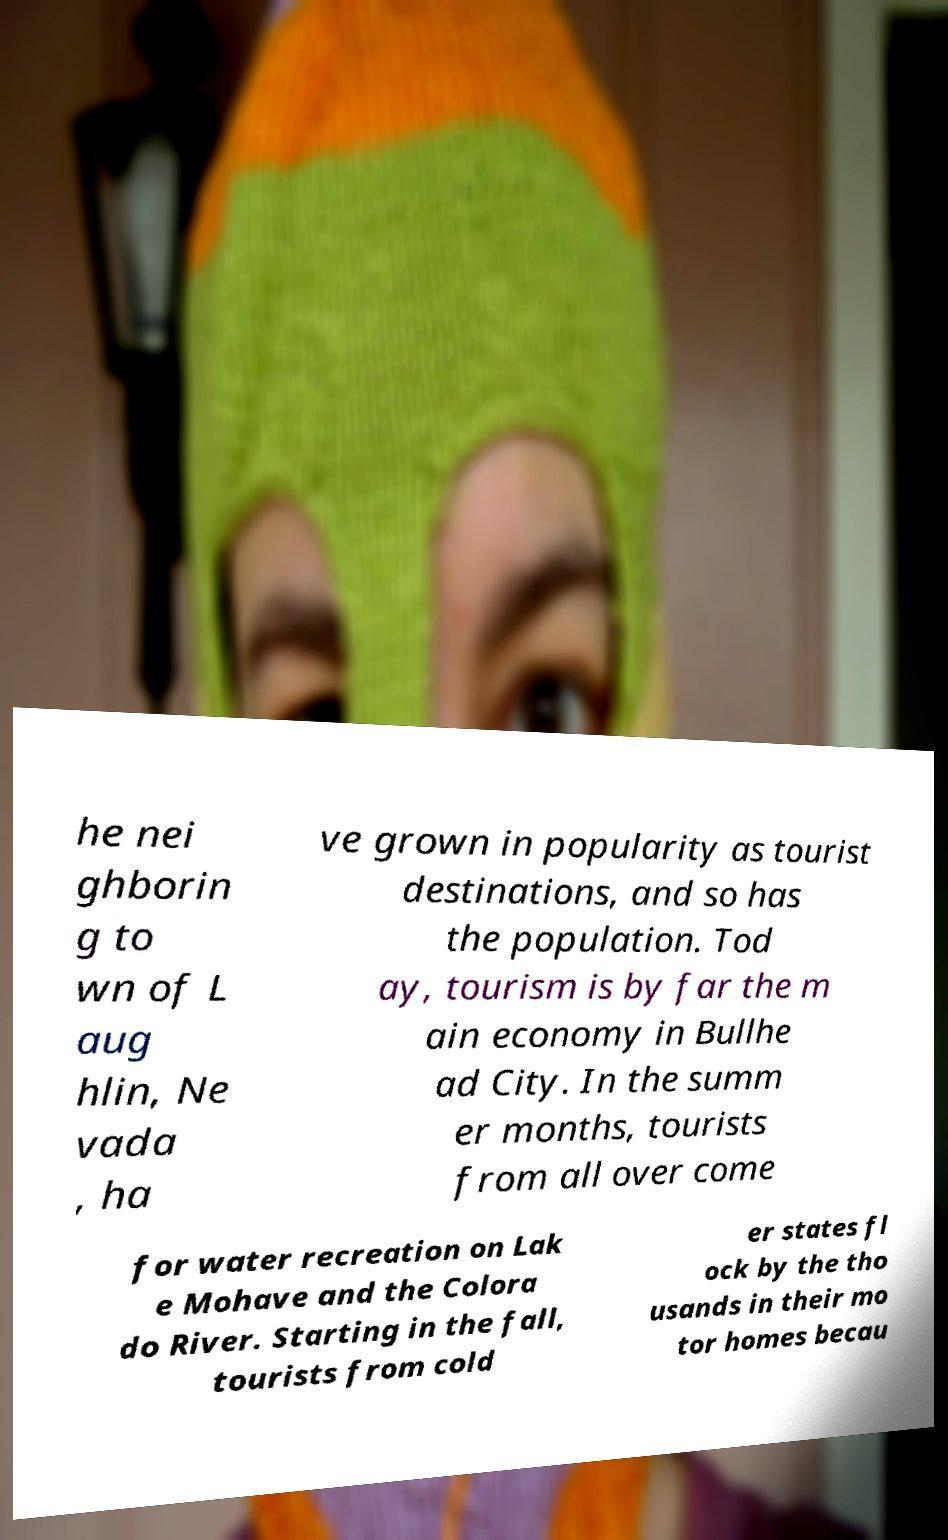There's text embedded in this image that I need extracted. Can you transcribe it verbatim? he nei ghborin g to wn of L aug hlin, Ne vada , ha ve grown in popularity as tourist destinations, and so has the population. Tod ay, tourism is by far the m ain economy in Bullhe ad City. In the summ er months, tourists from all over come for water recreation on Lak e Mohave and the Colora do River. Starting in the fall, tourists from cold er states fl ock by the tho usands in their mo tor homes becau 